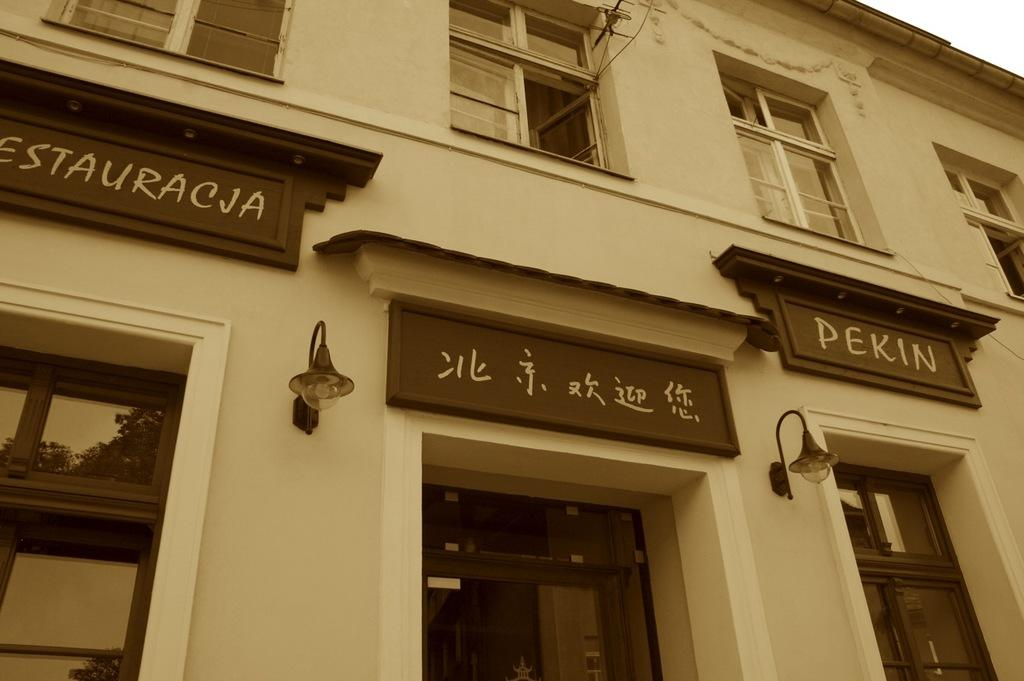What type of structure is present in the image? There is a building in the image. What feature can be seen on the building? There are windows in the building. What type of equipment is visible in the image? There are electric antennas in the image. What signage is present in the image? There are name boards in the image. What type of lighting is present in the image? There are electric lights in the image. What type of zipper can be seen on the building in the image? There is no zipper present on the building in the image. What level of experience is required to begin using the electric lights in the image? The image does not provide information about the level of experience required to use the electric lights. 